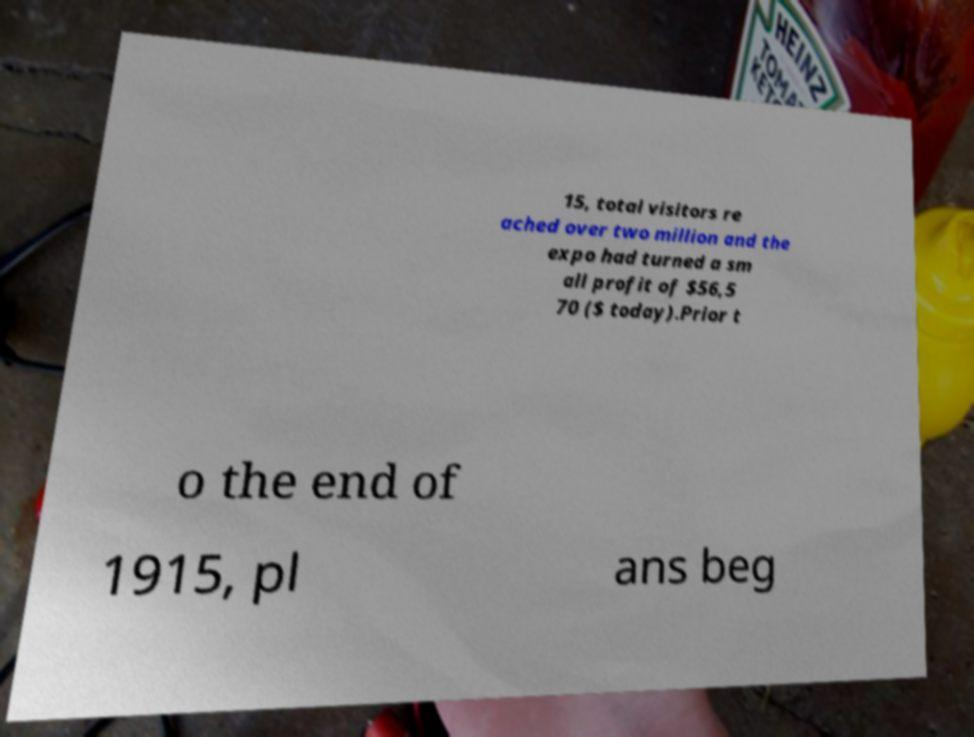Please identify and transcribe the text found in this image. 15, total visitors re ached over two million and the expo had turned a sm all profit of $56,5 70 ($ today).Prior t o the end of 1915, pl ans beg 